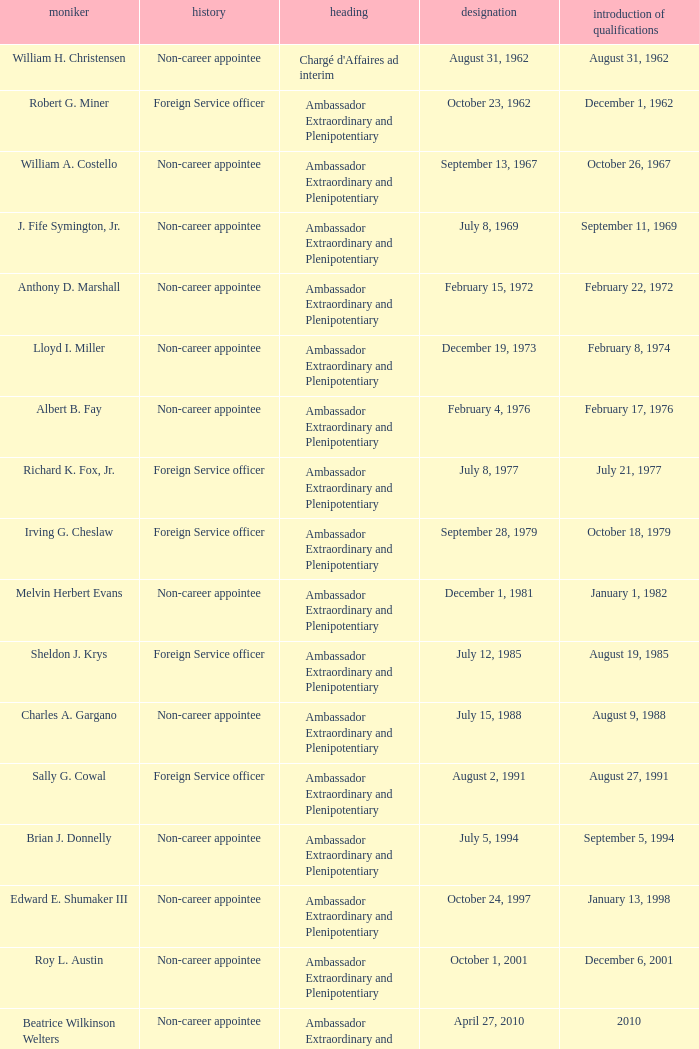Would you be able to parse every entry in this table? {'header': ['moniker', 'history', 'heading', 'designation', 'introduction of qualifications'], 'rows': [['William H. Christensen', 'Non-career appointee', "Chargé d'Affaires ad interim", 'August 31, 1962', 'August 31, 1962'], ['Robert G. Miner', 'Foreign Service officer', 'Ambassador Extraordinary and Plenipotentiary', 'October 23, 1962', 'December 1, 1962'], ['William A. Costello', 'Non-career appointee', 'Ambassador Extraordinary and Plenipotentiary', 'September 13, 1967', 'October 26, 1967'], ['J. Fife Symington, Jr.', 'Non-career appointee', 'Ambassador Extraordinary and Plenipotentiary', 'July 8, 1969', 'September 11, 1969'], ['Anthony D. Marshall', 'Non-career appointee', 'Ambassador Extraordinary and Plenipotentiary', 'February 15, 1972', 'February 22, 1972'], ['Lloyd I. Miller', 'Non-career appointee', 'Ambassador Extraordinary and Plenipotentiary', 'December 19, 1973', 'February 8, 1974'], ['Albert B. Fay', 'Non-career appointee', 'Ambassador Extraordinary and Plenipotentiary', 'February 4, 1976', 'February 17, 1976'], ['Richard K. Fox, Jr.', 'Foreign Service officer', 'Ambassador Extraordinary and Plenipotentiary', 'July 8, 1977', 'July 21, 1977'], ['Irving G. Cheslaw', 'Foreign Service officer', 'Ambassador Extraordinary and Plenipotentiary', 'September 28, 1979', 'October 18, 1979'], ['Melvin Herbert Evans', 'Non-career appointee', 'Ambassador Extraordinary and Plenipotentiary', 'December 1, 1981', 'January 1, 1982'], ['Sheldon J. Krys', 'Foreign Service officer', 'Ambassador Extraordinary and Plenipotentiary', 'July 12, 1985', 'August 19, 1985'], ['Charles A. Gargano', 'Non-career appointee', 'Ambassador Extraordinary and Plenipotentiary', 'July 15, 1988', 'August 9, 1988'], ['Sally G. Cowal', 'Foreign Service officer', 'Ambassador Extraordinary and Plenipotentiary', 'August 2, 1991', 'August 27, 1991'], ['Brian J. Donnelly', 'Non-career appointee', 'Ambassador Extraordinary and Plenipotentiary', 'July 5, 1994', 'September 5, 1994'], ['Edward E. Shumaker III', 'Non-career appointee', 'Ambassador Extraordinary and Plenipotentiary', 'October 24, 1997', 'January 13, 1998'], ['Roy L. Austin', 'Non-career appointee', 'Ambassador Extraordinary and Plenipotentiary', 'October 1, 2001', 'December 6, 2001'], ['Beatrice Wilkinson Welters', 'Non-career appointee', 'Ambassador Extraordinary and Plenipotentiary', 'April 27, 2010', '2010'], ['Margaret B. Diop', 'Foreign Service officer', "Chargé d'Affaires ad interim", 'October 2012', 'Unknown']]} What was Anthony D. Marshall's title? Ambassador Extraordinary and Plenipotentiary. 